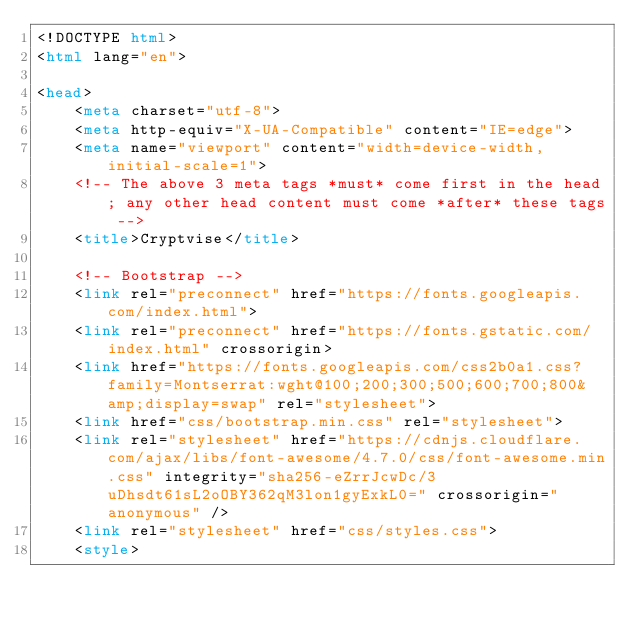Convert code to text. <code><loc_0><loc_0><loc_500><loc_500><_HTML_><!DOCTYPE html>
<html lang="en">
  
<head>
    <meta charset="utf-8">
    <meta http-equiv="X-UA-Compatible" content="IE=edge">
    <meta name="viewport" content="width=device-width, initial-scale=1">
    <!-- The above 3 meta tags *must* come first in the head; any other head content must come *after* these tags -->
    <title>Cryptvise</title>

    <!-- Bootstrap -->
    <link rel="preconnect" href="https://fonts.googleapis.com/index.html">
    <link rel="preconnect" href="https://fonts.gstatic.com/index.html" crossorigin>
    <link href="https://fonts.googleapis.com/css2b0a1.css?family=Montserrat:wght@100;200;300;500;600;700;800&amp;display=swap" rel="stylesheet">
    <link href="css/bootstrap.min.css" rel="stylesheet">
    <link rel="stylesheet" href="https://cdnjs.cloudflare.com/ajax/libs/font-awesome/4.7.0/css/font-awesome.min.css" integrity="sha256-eZrrJcwDc/3uDhsdt61sL2oOBY362qM3lon1gyExkL0=" crossorigin="anonymous" />
    <link rel="stylesheet" href="css/styles.css">
    <style></code> 